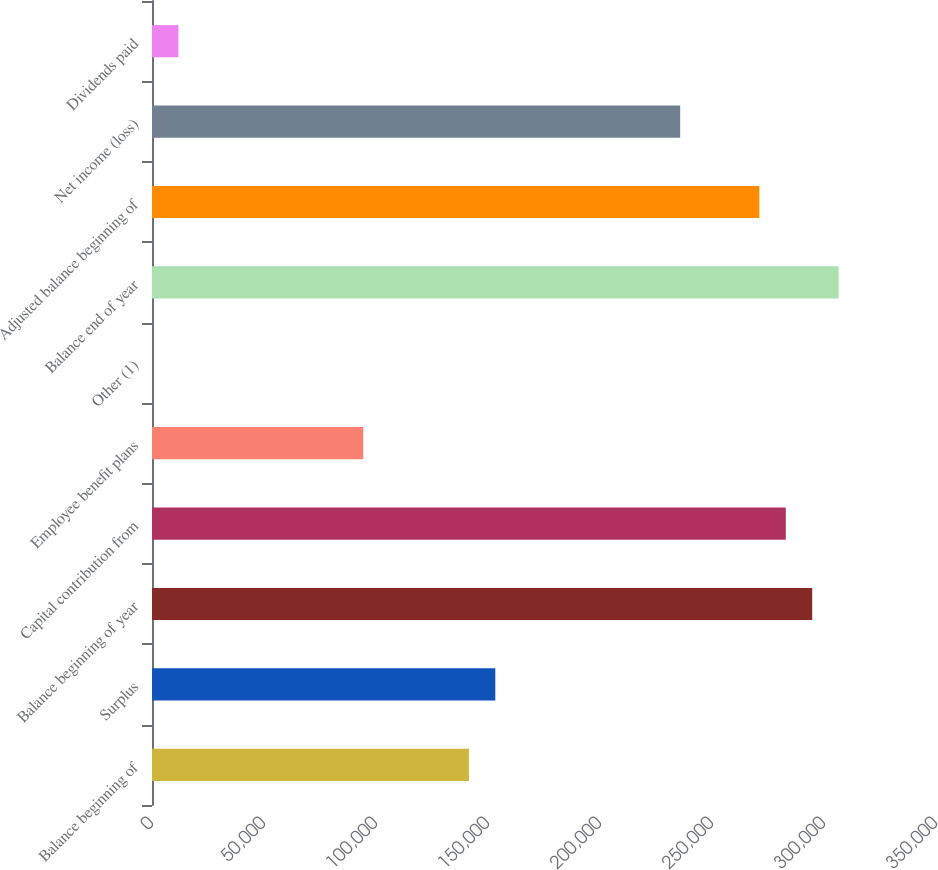Convert chart. <chart><loc_0><loc_0><loc_500><loc_500><bar_chart><fcel>Balance beginning of<fcel>Surplus<fcel>Balance beginning of year<fcel>Capital contribution from<fcel>Employee benefit plans<fcel>Other (1)<fcel>Balance end of year<fcel>Adjusted balance beginning of<fcel>Net income (loss)<fcel>Dividends paid<nl><fcel>141471<fcel>153261<fcel>294731<fcel>282942<fcel>94314.6<fcel>1<fcel>306520<fcel>271153<fcel>235785<fcel>11790.2<nl></chart> 